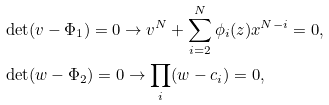<formula> <loc_0><loc_0><loc_500><loc_500>& \det ( v - \Phi _ { 1 } ) = 0 \rightarrow v ^ { N } + \sum _ { i = 2 } ^ { N } \phi _ { i } ( z ) x ^ { N - i } = 0 , \\ & \det ( w - \Phi _ { 2 } ) = 0 \rightarrow \prod _ { i } ( w - c _ { i } ) = 0 ,</formula> 